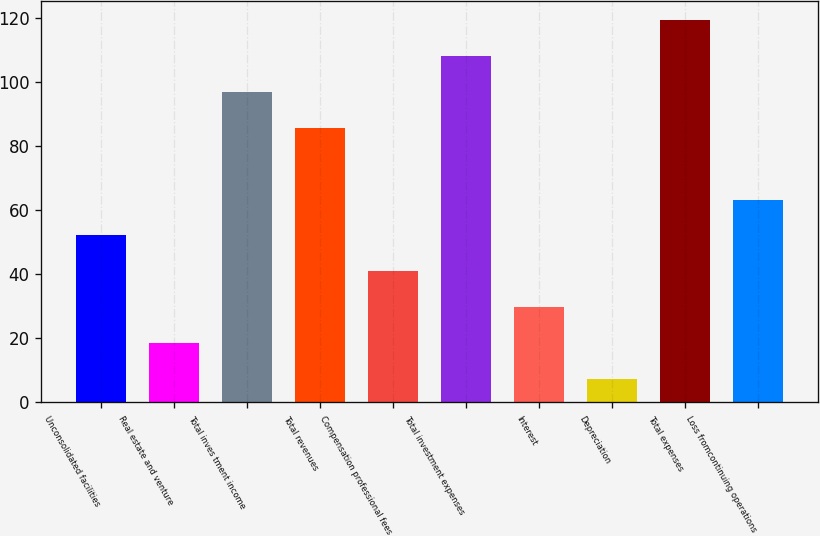Convert chart. <chart><loc_0><loc_0><loc_500><loc_500><bar_chart><fcel>Unconsolidated facilities<fcel>Real estate and venture<fcel>Total inves tment income<fcel>Total revenues<fcel>Compensation professional fees<fcel>Total investment expenses<fcel>Interest<fcel>Depreciation<fcel>Total expenses<fcel>Loss fromcontinuing operations<nl><fcel>52.18<fcel>18.52<fcel>97.06<fcel>85.84<fcel>40.96<fcel>108.28<fcel>29.74<fcel>7.3<fcel>119.5<fcel>63.4<nl></chart> 